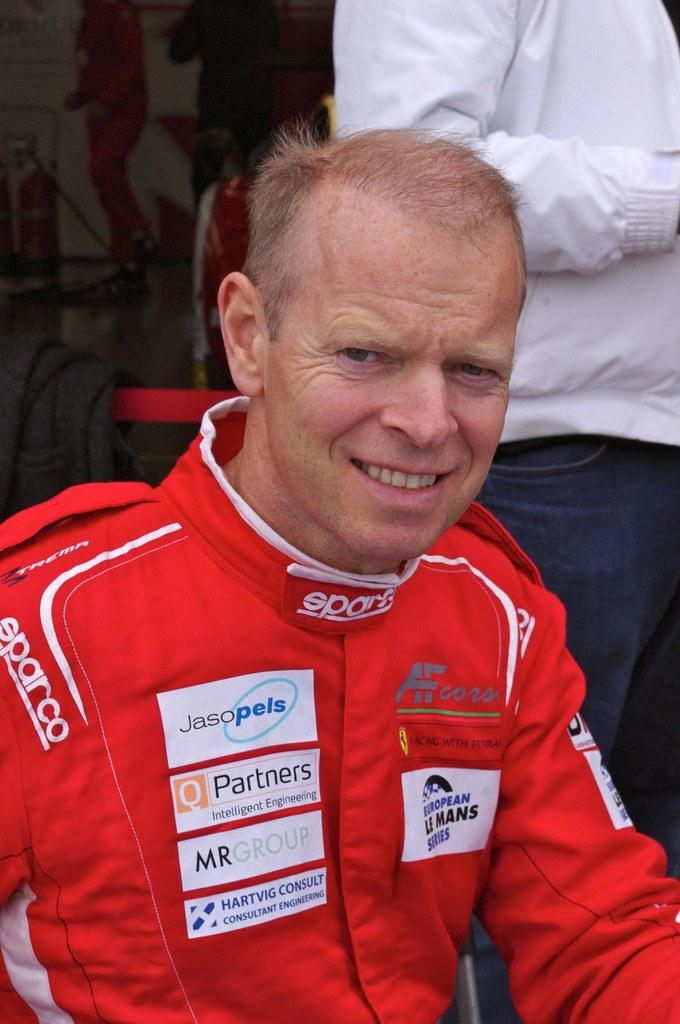Provide a one-sentence caption for the provided image. European Le Mans Series reads the patch on this driver's uniform. 